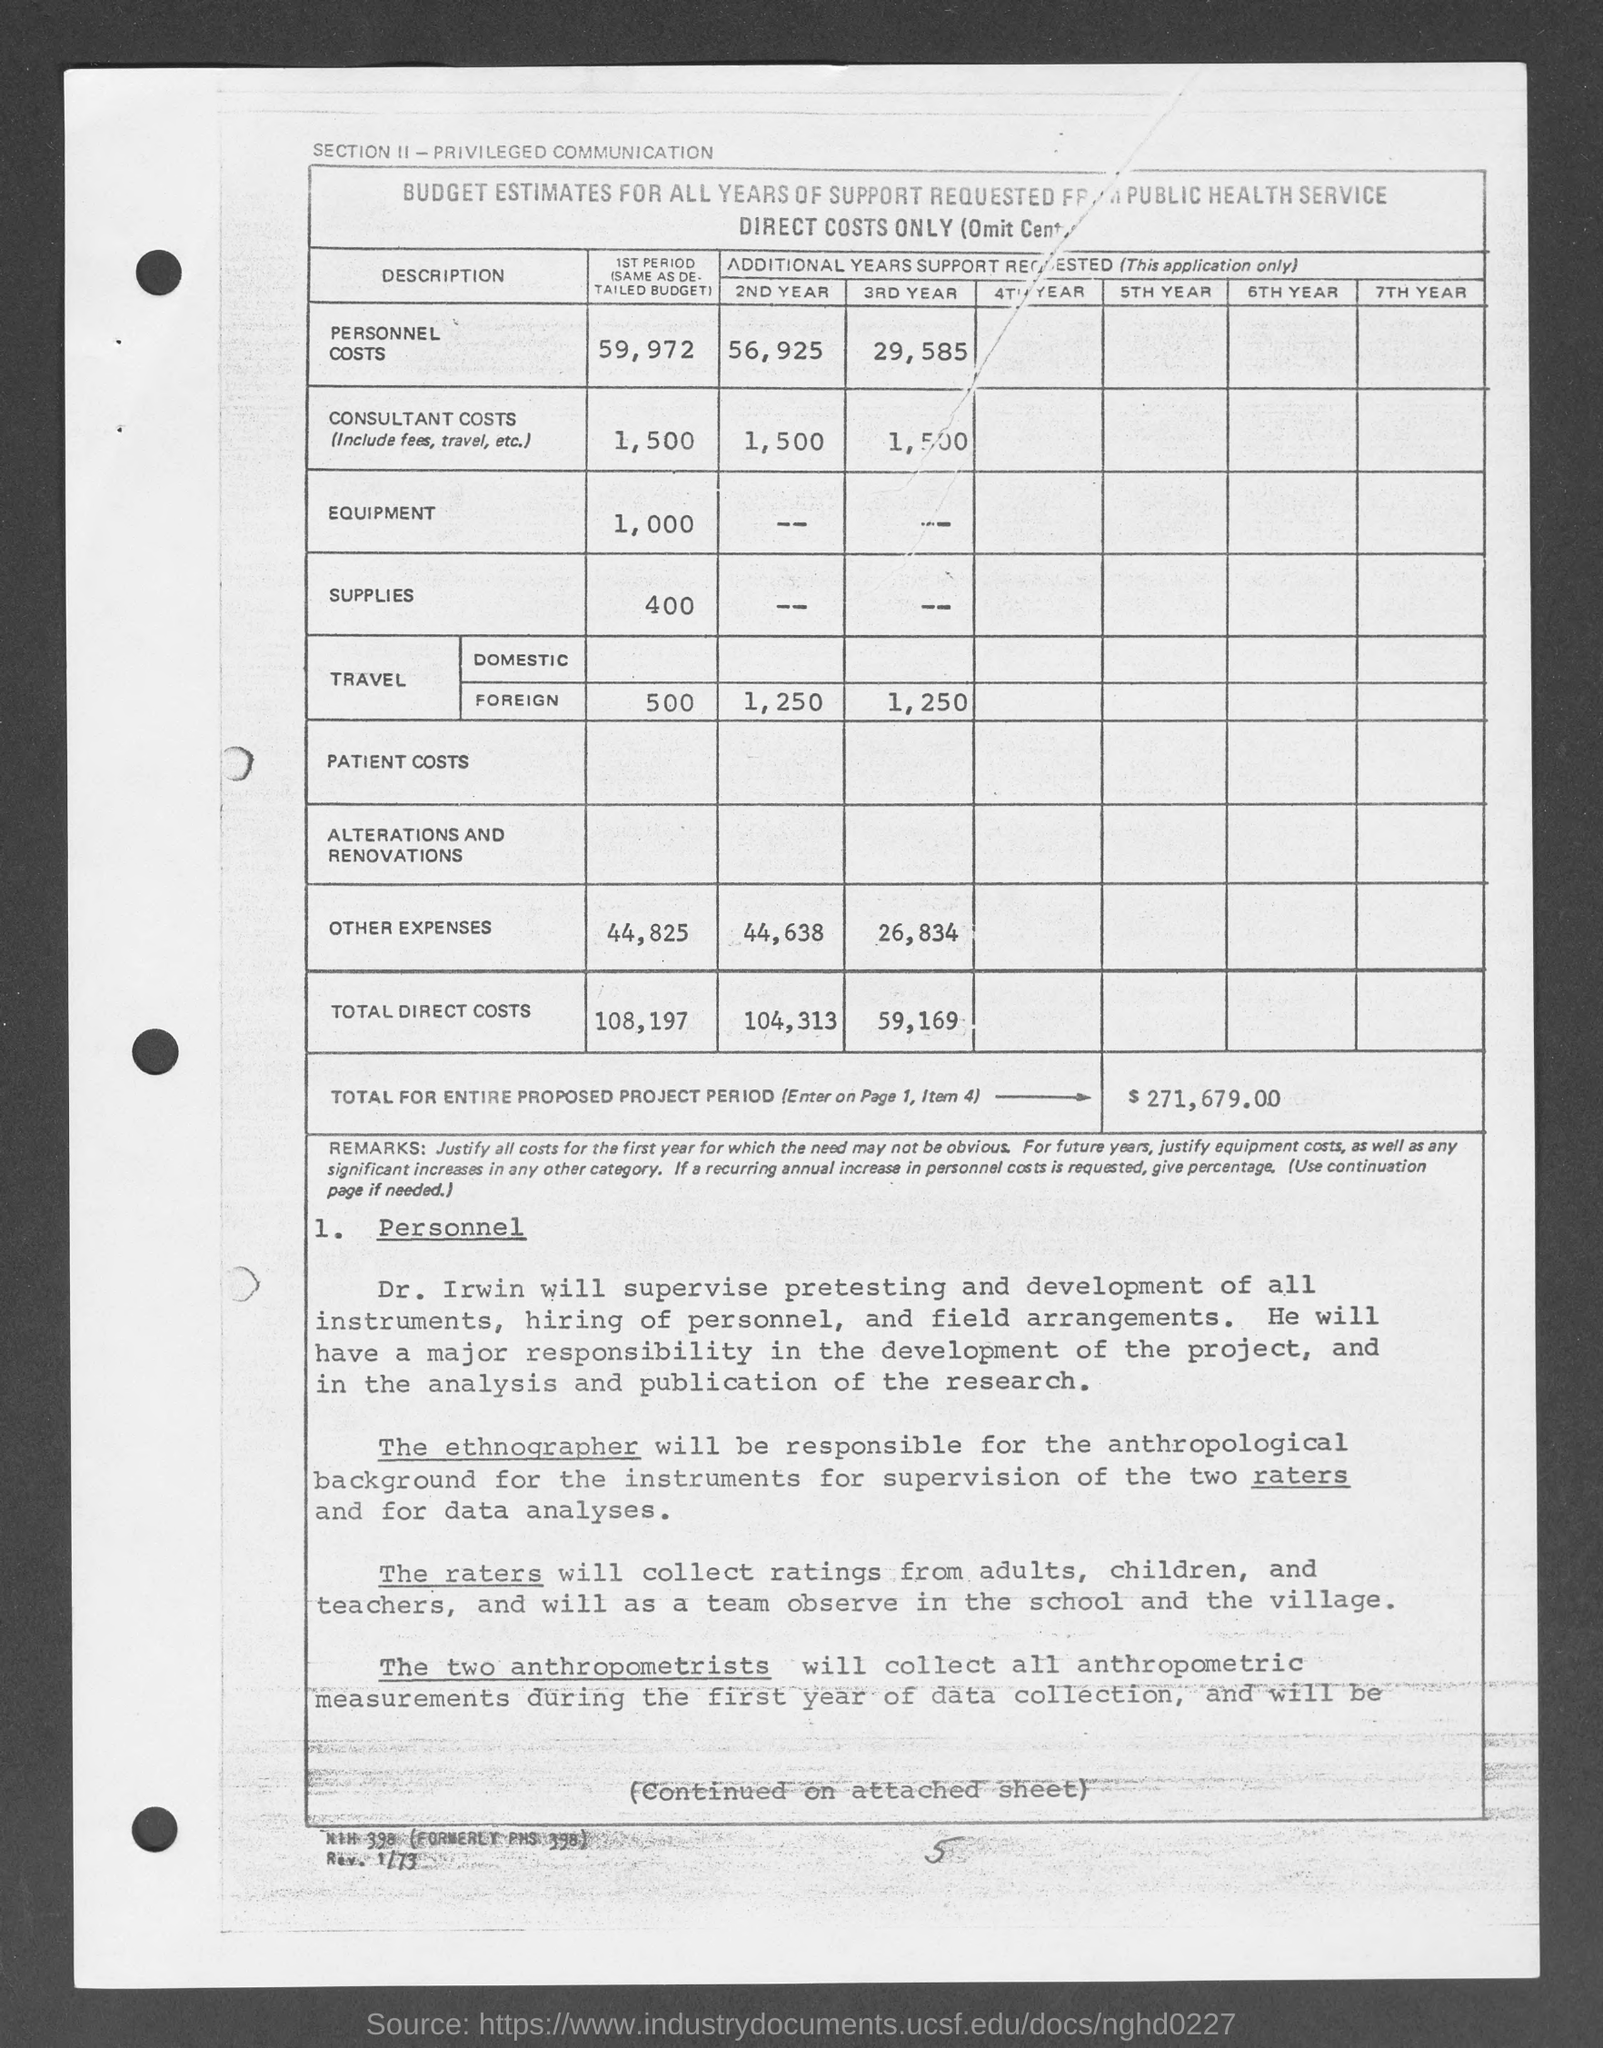What is the amount of personnel costs given in the 1st period ?
Keep it short and to the point. 59,972. What is the amount of budget estimates of personnel costs in the 2ns year ?
Provide a succinct answer. 56,925. What is the amount of consultant costs for the 1sr period as mentioned in the given page ?
Make the answer very short. 1,500. What is the amount of budget estimated for equipment during the 1st period ?
Your response must be concise. 1,000. What is the amount of other expenses during the 2nd year ?
Your response must be concise. 44,638. What is the amount of total direct costs of 3rd year as mentioned in the given page ?
Your response must be concise. 59,169. What is the amount for foreign travel during the 2nd year as mentioned in the given page ?
Your response must be concise. 1,250. What is the amount of entire proposed project period ?
Your answer should be very brief. $ 271,679.00. What is the amount of supplies during the 1st period as mentioned in the given page ?
Make the answer very short. 400. What is the amount of foreign travel during the 1st period mentioned in the given page ?
Offer a terse response. 500. 